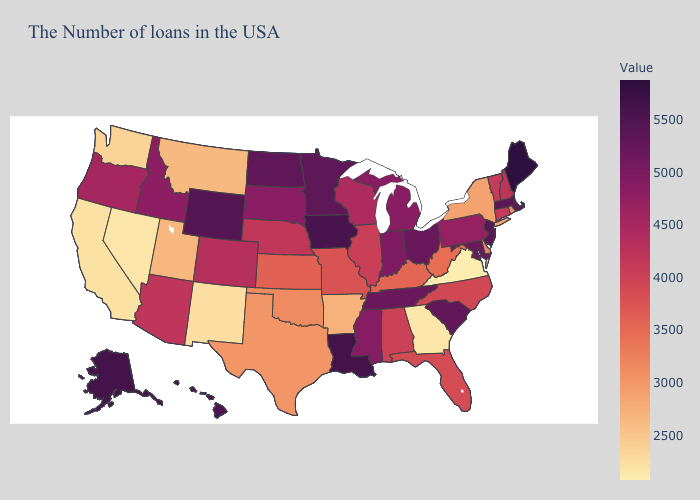Does Illinois have the highest value in the USA?
Concise answer only. No. Among the states that border Nevada , does Arizona have the highest value?
Keep it brief. No. Among the states that border Utah , which have the highest value?
Quick response, please. Wyoming. Which states have the lowest value in the USA?
Concise answer only. Virginia. Does New York have the lowest value in the USA?
Give a very brief answer. No. 